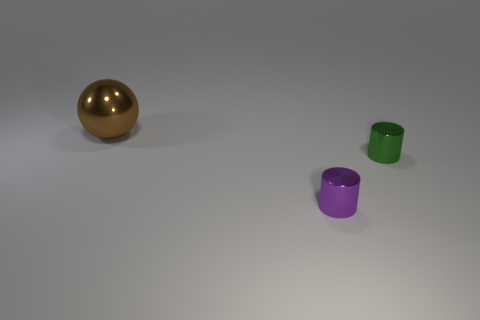Can you infer anything about the texture of the purple cylinder? The purple cylinder has a matte finish, as evidenced by the way it reflects light. Its surface seems smooth without any visible texture which differentiates it from the gold sphere's reflective surface. 